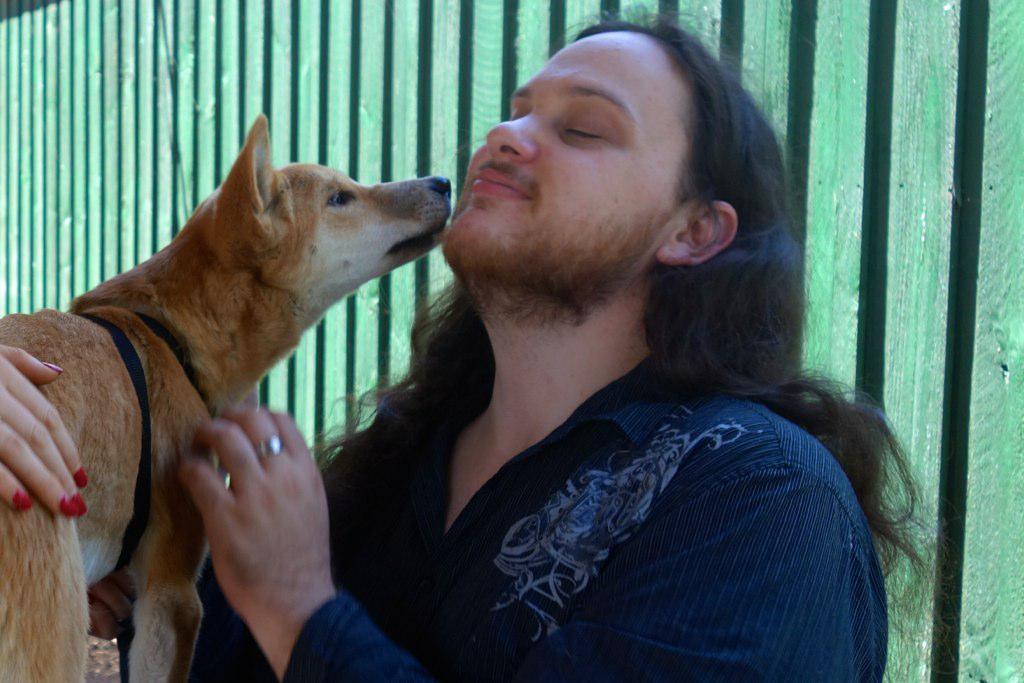In one or two sentences, can you explain what this image depicts? This picture shows a man standing and holding a dog with his hand and we see another human hand on the dog and we see a wooden fence. 